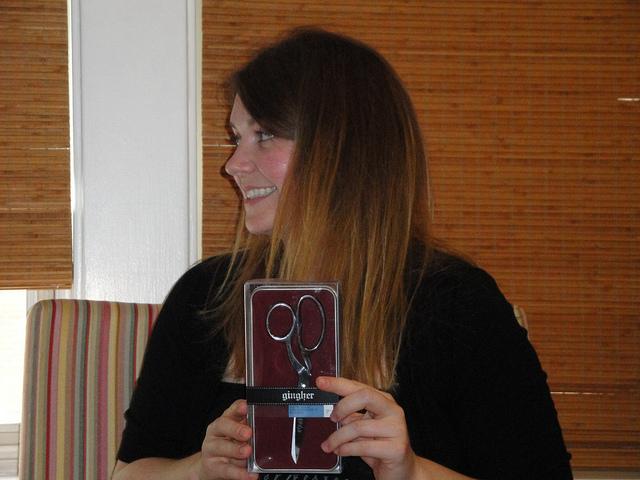What is covering the windows?
Write a very short answer. Blinds. What is she holding?
Concise answer only. Scissors. Is there anyone else in this picture?
Answer briefly. No. 